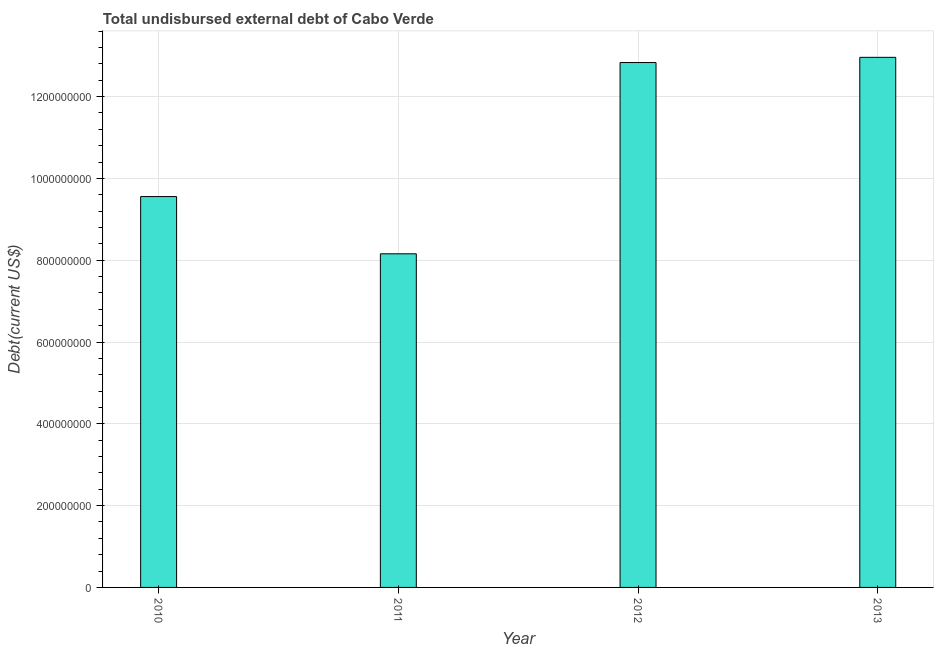Does the graph contain any zero values?
Your answer should be very brief. No. What is the title of the graph?
Provide a short and direct response. Total undisbursed external debt of Cabo Verde. What is the label or title of the Y-axis?
Your answer should be compact. Debt(current US$). What is the total debt in 2010?
Give a very brief answer. 9.56e+08. Across all years, what is the maximum total debt?
Your response must be concise. 1.30e+09. Across all years, what is the minimum total debt?
Offer a very short reply. 8.16e+08. In which year was the total debt minimum?
Keep it short and to the point. 2011. What is the sum of the total debt?
Make the answer very short. 4.35e+09. What is the difference between the total debt in 2010 and 2011?
Make the answer very short. 1.40e+08. What is the average total debt per year?
Ensure brevity in your answer.  1.09e+09. What is the median total debt?
Offer a very short reply. 1.12e+09. Do a majority of the years between 2011 and 2013 (inclusive) have total debt greater than 1040000000 US$?
Offer a terse response. Yes. What is the ratio of the total debt in 2012 to that in 2013?
Your response must be concise. 0.99. What is the difference between the highest and the second highest total debt?
Your response must be concise. 1.27e+07. What is the difference between the highest and the lowest total debt?
Provide a succinct answer. 4.80e+08. Are all the bars in the graph horizontal?
Your response must be concise. No. What is the Debt(current US$) of 2010?
Ensure brevity in your answer.  9.56e+08. What is the Debt(current US$) of 2011?
Give a very brief answer. 8.16e+08. What is the Debt(current US$) of 2012?
Your answer should be compact. 1.28e+09. What is the Debt(current US$) of 2013?
Provide a succinct answer. 1.30e+09. What is the difference between the Debt(current US$) in 2010 and 2011?
Make the answer very short. 1.40e+08. What is the difference between the Debt(current US$) in 2010 and 2012?
Provide a succinct answer. -3.28e+08. What is the difference between the Debt(current US$) in 2010 and 2013?
Your answer should be very brief. -3.40e+08. What is the difference between the Debt(current US$) in 2011 and 2012?
Provide a short and direct response. -4.68e+08. What is the difference between the Debt(current US$) in 2011 and 2013?
Provide a succinct answer. -4.80e+08. What is the difference between the Debt(current US$) in 2012 and 2013?
Your response must be concise. -1.27e+07. What is the ratio of the Debt(current US$) in 2010 to that in 2011?
Give a very brief answer. 1.17. What is the ratio of the Debt(current US$) in 2010 to that in 2012?
Provide a succinct answer. 0.74. What is the ratio of the Debt(current US$) in 2010 to that in 2013?
Ensure brevity in your answer.  0.74. What is the ratio of the Debt(current US$) in 2011 to that in 2012?
Give a very brief answer. 0.64. What is the ratio of the Debt(current US$) in 2011 to that in 2013?
Offer a very short reply. 0.63. 